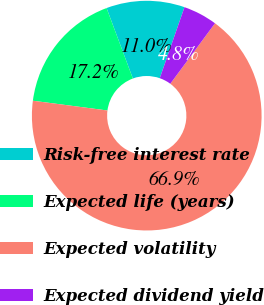Convert chart. <chart><loc_0><loc_0><loc_500><loc_500><pie_chart><fcel>Risk-free interest rate<fcel>Expected life (years)<fcel>Expected volatility<fcel>Expected dividend yield<nl><fcel>11.02%<fcel>17.24%<fcel>66.94%<fcel>4.8%<nl></chart> 